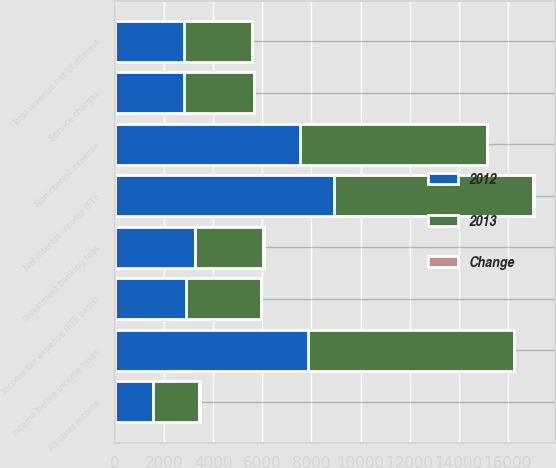Convert chart. <chart><loc_0><loc_0><loc_500><loc_500><stacked_bar_chart><ecel><fcel>Net interest income (FTE<fcel>Service charges<fcel>Investment banking fees<fcel>All other income<fcel>Total revenue net of interest<fcel>Noninterest expense<fcel>Income before income taxes<fcel>Income tax expense (FTE basis)<nl><fcel>2012<fcel>8914<fcel>2787<fcel>3235<fcel>1545<fcel>2790<fcel>7552<fcel>7854<fcel>2880<nl><fcel>2013<fcel>8135<fcel>2867<fcel>2793<fcel>1879<fcel>2790<fcel>7619<fcel>8397<fcel>3053<nl><fcel>Change<fcel>10<fcel>3<fcel>16<fcel>18<fcel>5<fcel>1<fcel>6<fcel>6<nl></chart> 